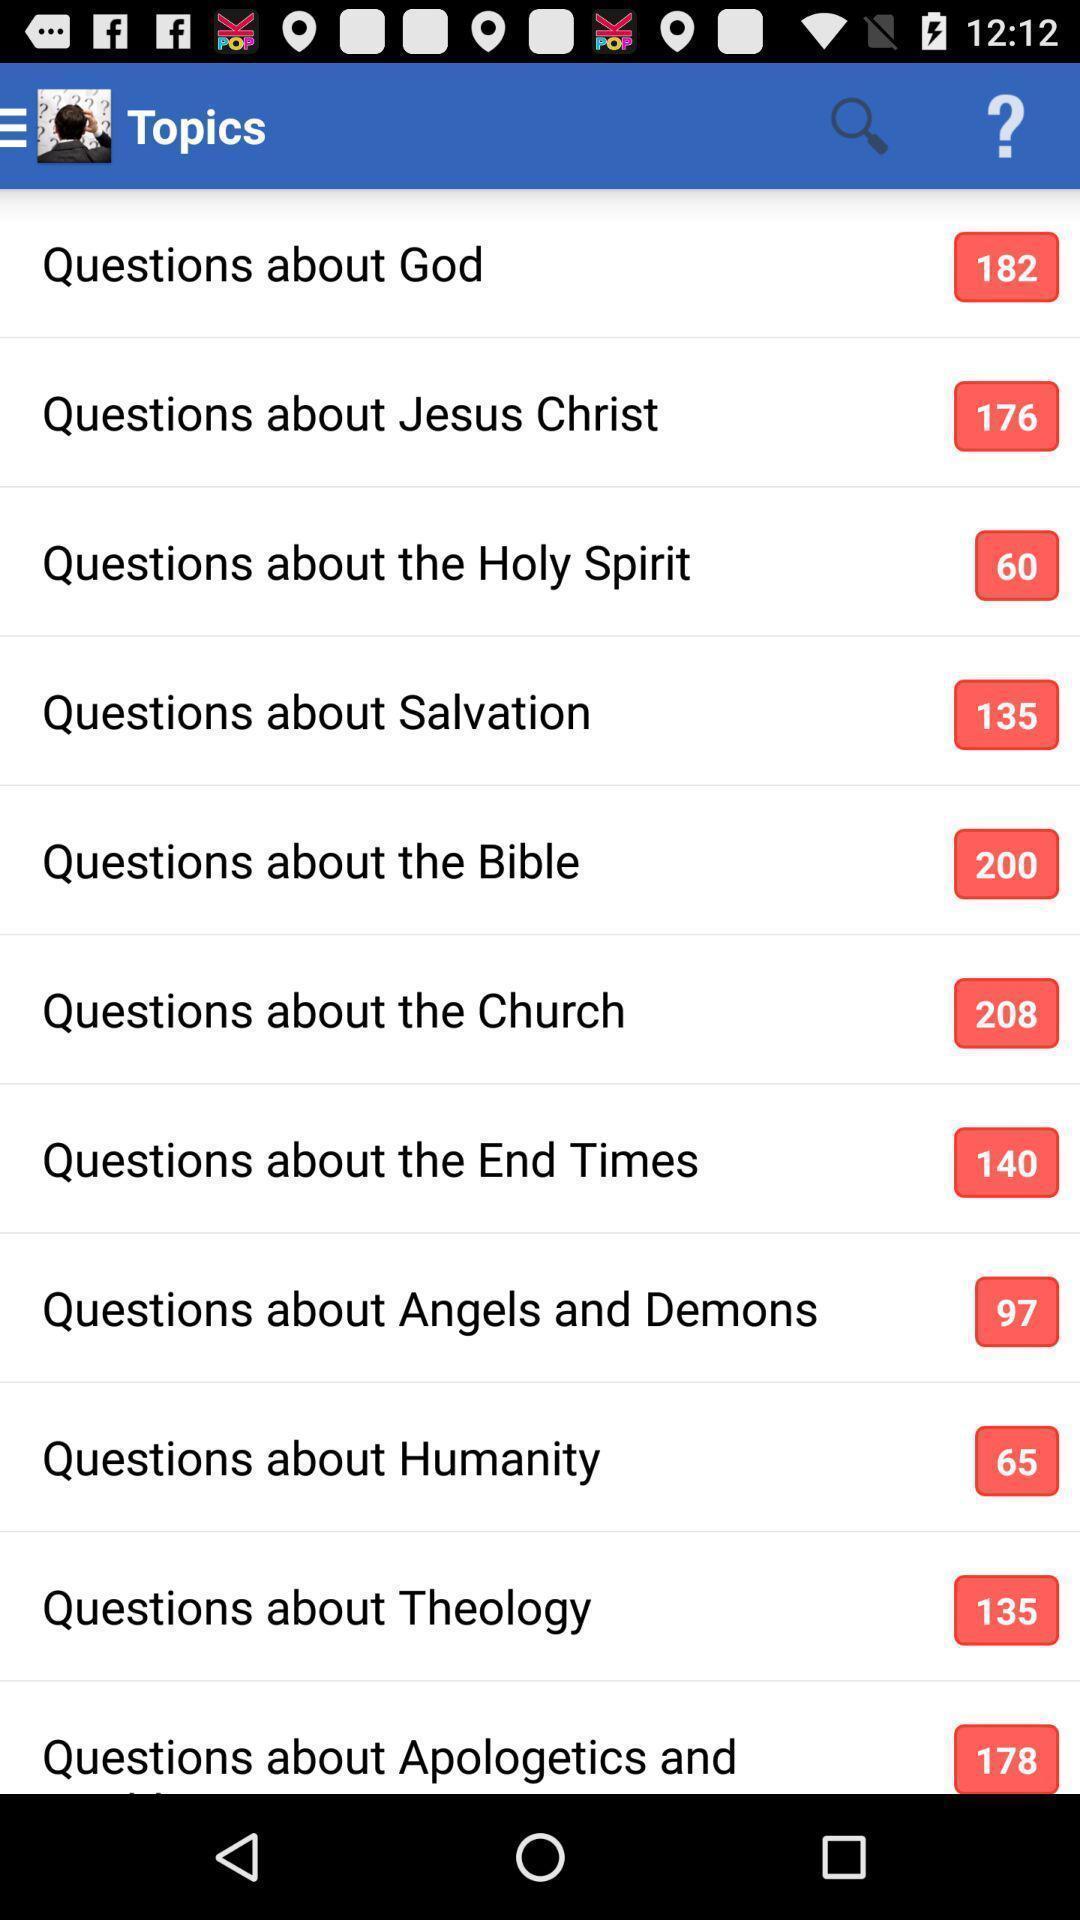What details can you identify in this image? Screen showing list of various topics. 